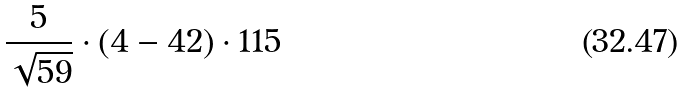Convert formula to latex. <formula><loc_0><loc_0><loc_500><loc_500>\frac { 5 } { \sqrt { 5 9 } } \cdot ( 4 - 4 2 ) \cdot 1 1 5</formula> 